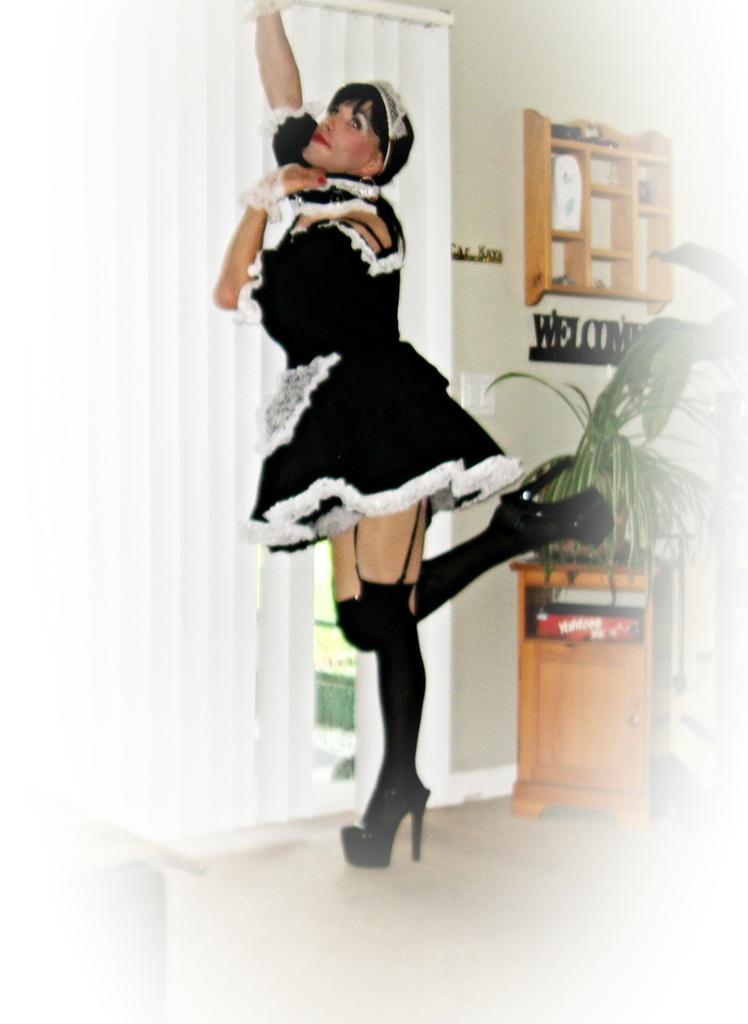Describe this image in one or two sentences. In this picture we can see a woman standing in the middle, on the right side there is a plant, in the background we can see a welcome board and a wall, we can see cupboard at the bottom, on the left side there is a curtain. 